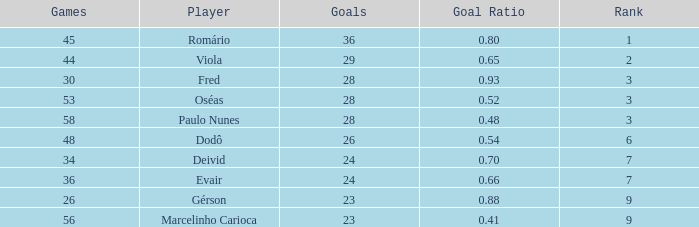How many goal ratios have rank of 2 with more than 44 games? 0.0. 